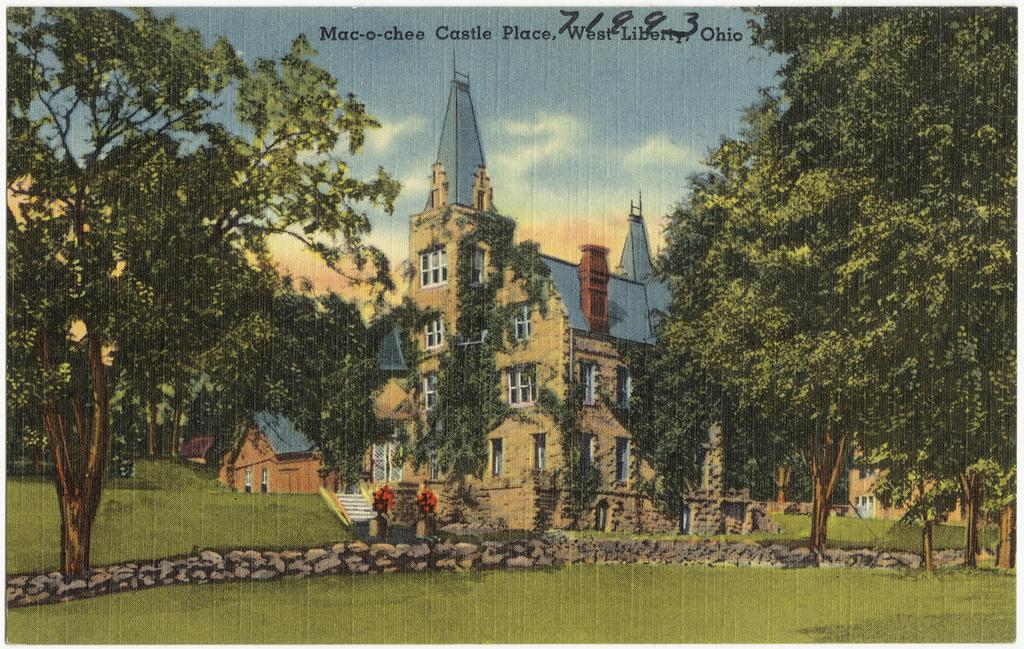What is present in the image that contains both images and text? There is a poster in the image that contains images and text. What type of holiday is depicted in the poster? There is no holiday depicted in the poster; it contains images and text, but no specific holiday is mentioned or shown. 